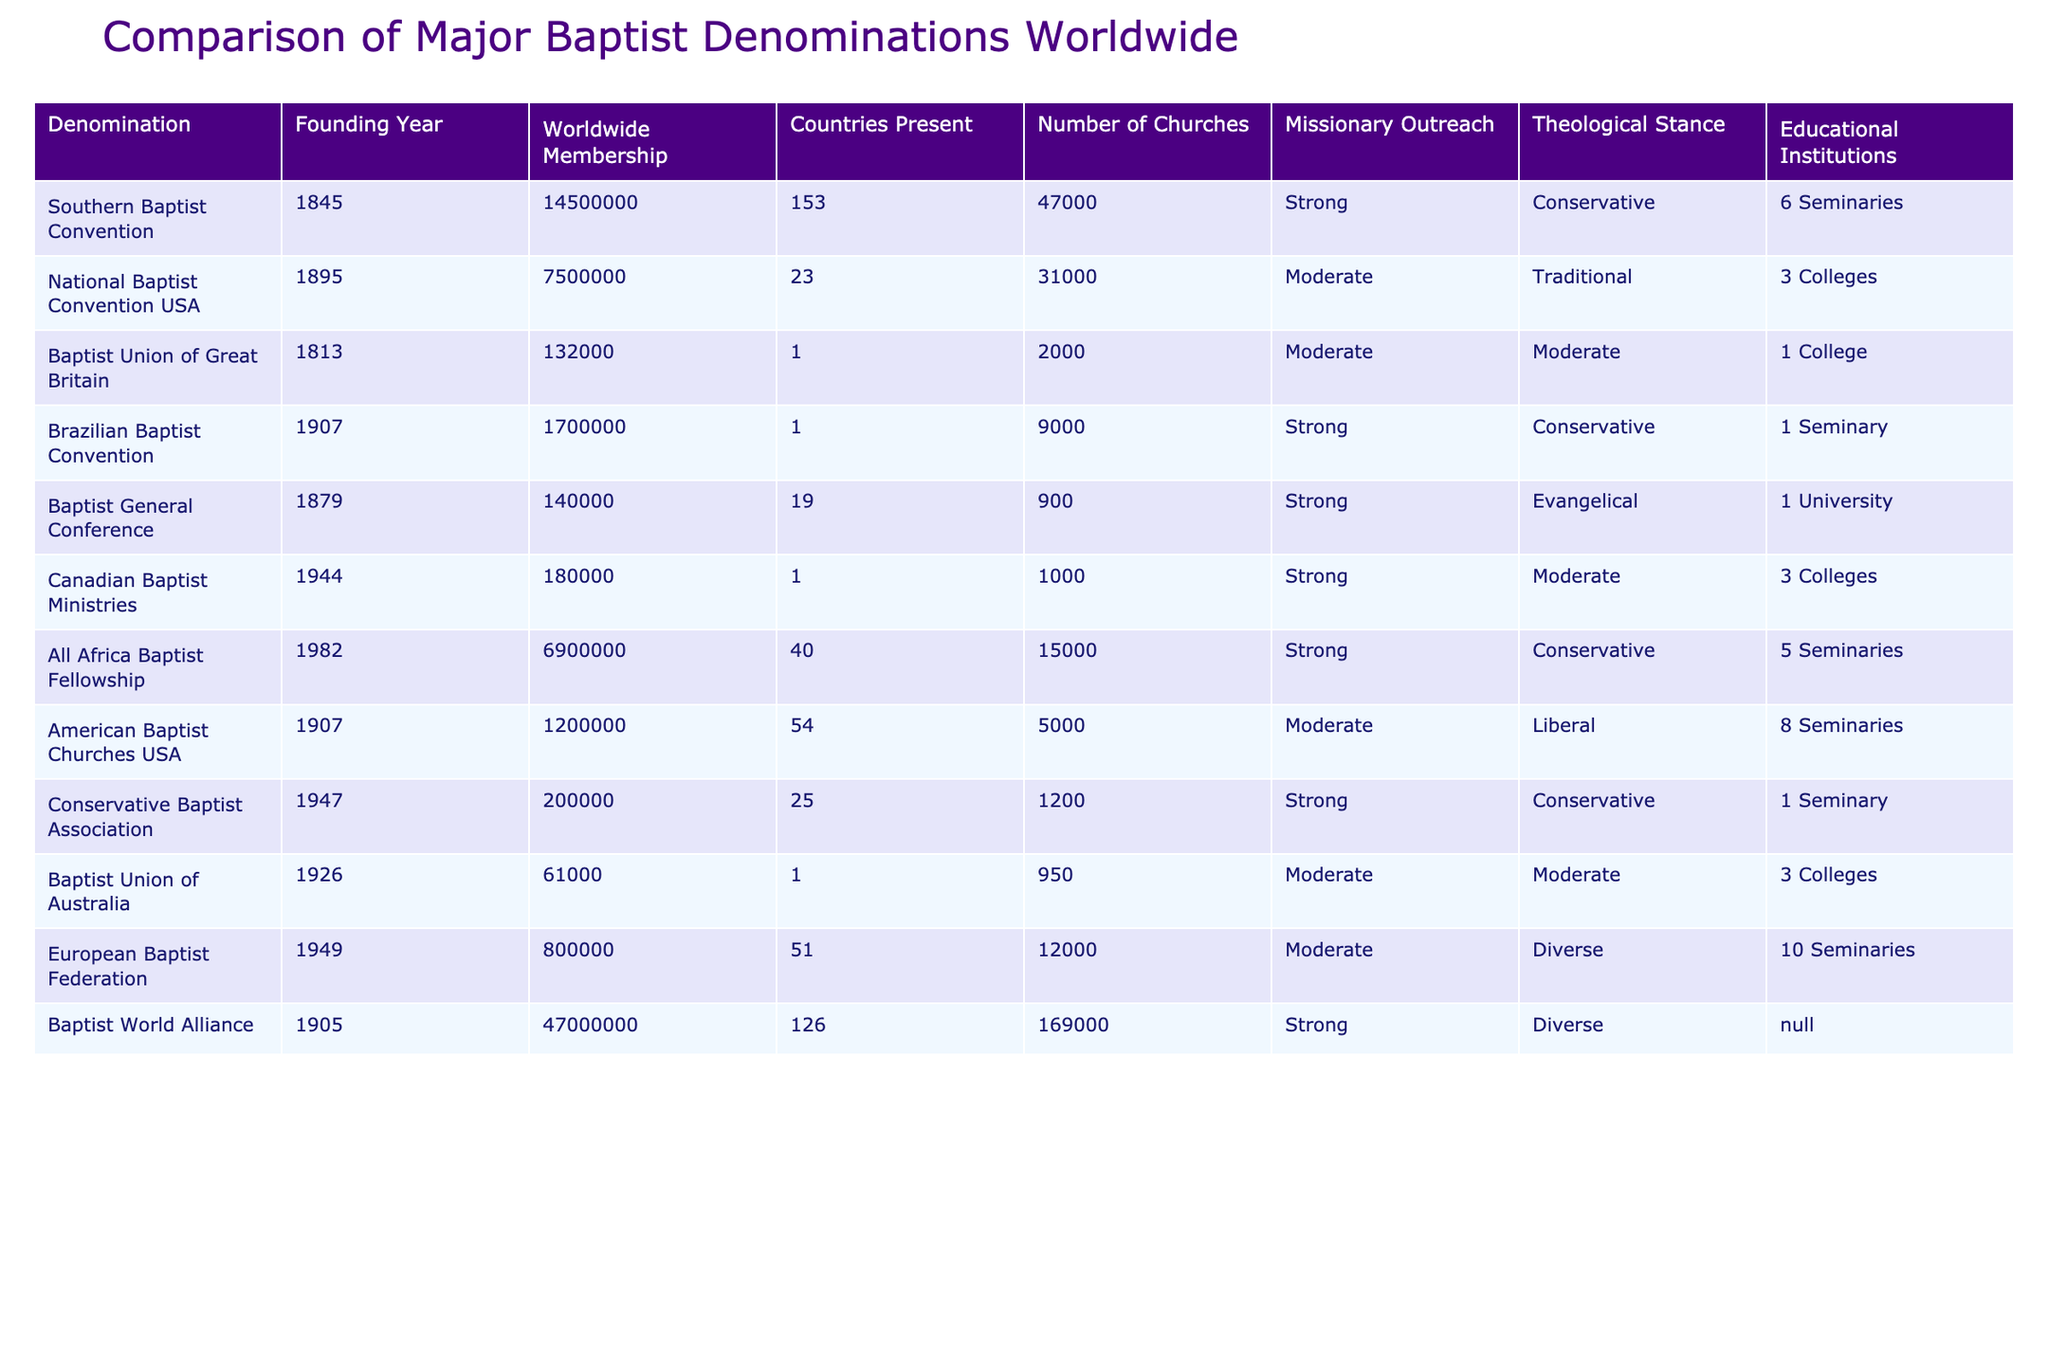What is the founding year of the Southern Baptist Convention? The Southern Baptist Convention was founded in the year indicated in the table. By looking at the relevant column, we see that it is noted as 1845.
Answer: 1845 How many countries are represented by the Baptist World Alliance? The table directly states that the Baptist World Alliance is present in 126 countries as listed under the 'Countries Present' column.
Answer: 126 Which denomination has the largest worldwide membership? By examining the 'Worldwide Membership' column, the Baptists World Alliance's membership is the highest at 47,000,000.
Answer: 47,000,000 How many seminaries are associated with the American Baptist Churches USA? The table specifies that the American Baptist Churches USA has 8 seminaries associated with it under the 'Educational Institutions' column.
Answer: 8 Which Baptist denomination was founded most recently, and what is its founding year? We need to look at the 'Founding Year' column and find the latest year mentioned. The most recent denomination listed is the Canadian Baptist Ministries, founded in 1944.
Answer: Canadian Baptist Ministries, 1944 What is the total number of churches represented by the Baptist General Conference and the Baptist Union of Australia combined? We sum the number of churches from both denominations: Baptist General Conference has 900 and Baptist Union of Australia has 950, so 900 + 950 = 1850.
Answer: 1850 Is the number of countries present for the Brazilian Baptist Convention greater than that of the Canadian Baptist Ministries? By checking the table, we find the Brazilian Baptist Convention is present in 1 country and the Canadian Baptist Ministries is also in 1 country; therefore, they are not greater than each other. This is a No.
Answer: No What percentage of the total worldwide membership is represented by the Southern Baptist Convention when summing all memberships? First, we find the total membership by summing all the membership numbers (14,500,000 + 7,500,000 + 132,000 + 1,700,000 + 140,000 + 180,000 + 6,900,000 + 1,200,000 + 200,000 + 61,000 + 800,000 + 47,000,000 = 78,051,000). Then we calculate the percentage of the Southern Baptist Convention's membership: (14,500,000 / 78,051,000) * 100 ≈ 18.57%.
Answer: Approximately 18.57% Which Baptist denomination has the strongest missionary outreach? By examining the 'Missionary Outreach' column, we determine that the following denominations are noted as having 'Strong' outreach capabilities: Southern Baptist Convention, Brazilian Baptist Convention, All Africa Baptist Fellowship, Conservative Baptist Association, and Baptist World Alliance. However, we notice that the Baptist World Alliance has the largest membership, which implies a high level of outreach.
Answer: Baptist World Alliance What is the median founding year of these Baptist denominations? We list the founding years in order: 1813, 1845, 1879, 1895, 1905, 1907, 1944, 1947, 1949, 1982. Since there are 10 denominations, the median will be the average of the 5th and 6th years: (1905 + 1907) / 2 = 1906.
Answer: 1906 